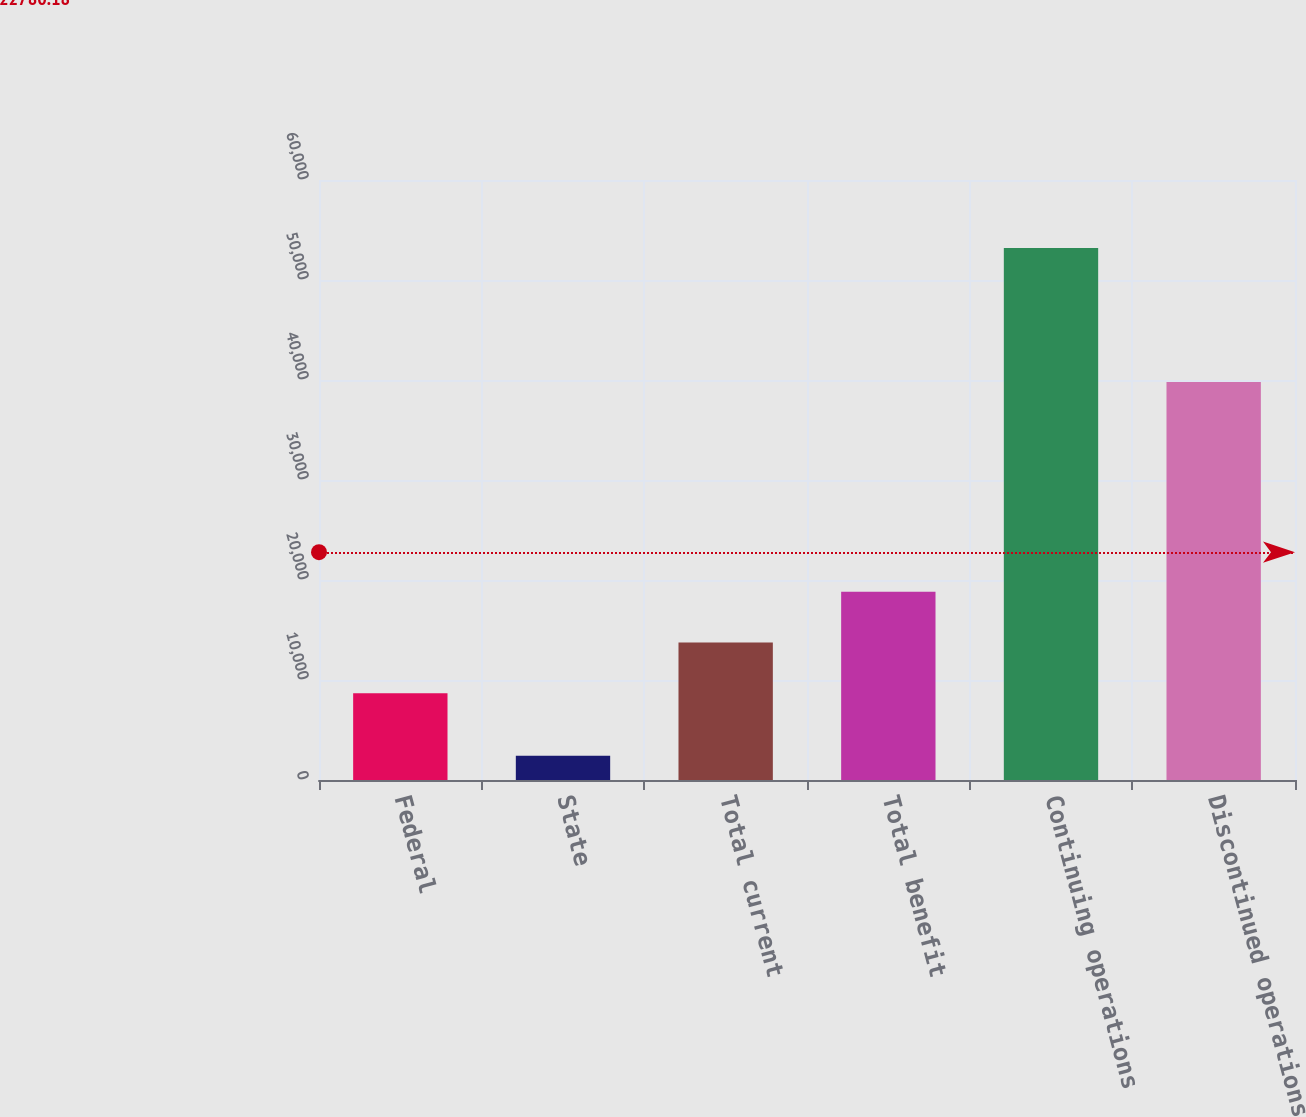Convert chart to OTSL. <chart><loc_0><loc_0><loc_500><loc_500><bar_chart><fcel>Federal<fcel>State<fcel>Total current<fcel>Total benefit<fcel>Continuing operations<fcel>Discontinued operations<nl><fcel>8678<fcel>2415<fcel>13756.7<fcel>18835.4<fcel>53202<fcel>39794<nl></chart> 